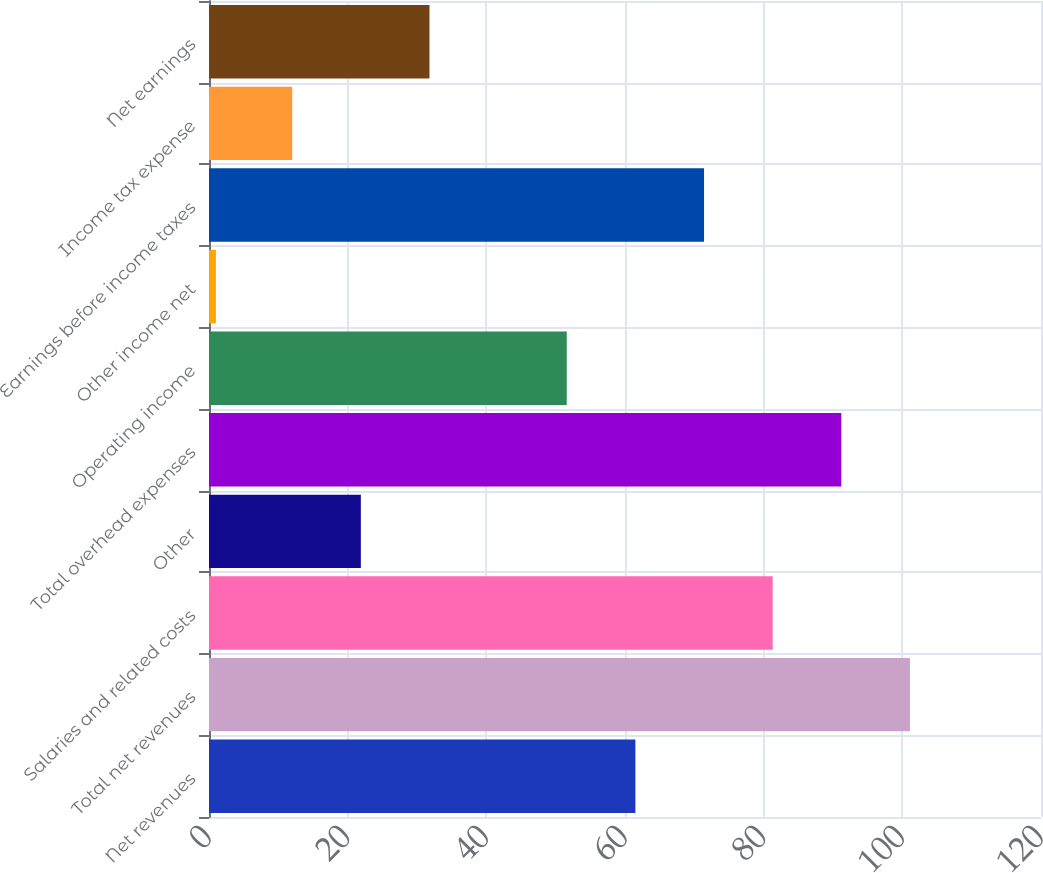<chart> <loc_0><loc_0><loc_500><loc_500><bar_chart><fcel>Net revenues<fcel>Total net revenues<fcel>Salaries and related costs<fcel>Other<fcel>Total overhead expenses<fcel>Operating income<fcel>Other income net<fcel>Earnings before income taxes<fcel>Income tax expense<fcel>Net earnings<nl><fcel>61.5<fcel>101.1<fcel>81.3<fcel>21.9<fcel>91.2<fcel>51.6<fcel>1<fcel>71.4<fcel>12<fcel>31.8<nl></chart> 